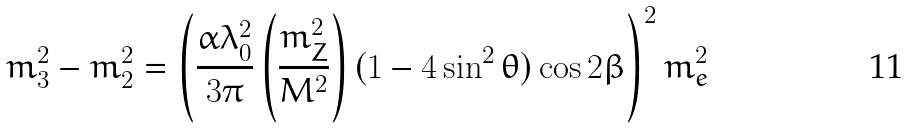<formula> <loc_0><loc_0><loc_500><loc_500>m _ { 3 } ^ { 2 } - m _ { 2 } ^ { 2 } = \left ( \frac { \alpha \lambda _ { 0 } ^ { 2 } } { 3 \pi } \left ( \frac { m _ { Z } ^ { 2 } } { M ^ { 2 } } \right ) ( 1 - 4 \sin ^ { 2 } \theta ) \cos 2 \beta \right ) ^ { 2 } m _ { e } ^ { 2 }</formula> 